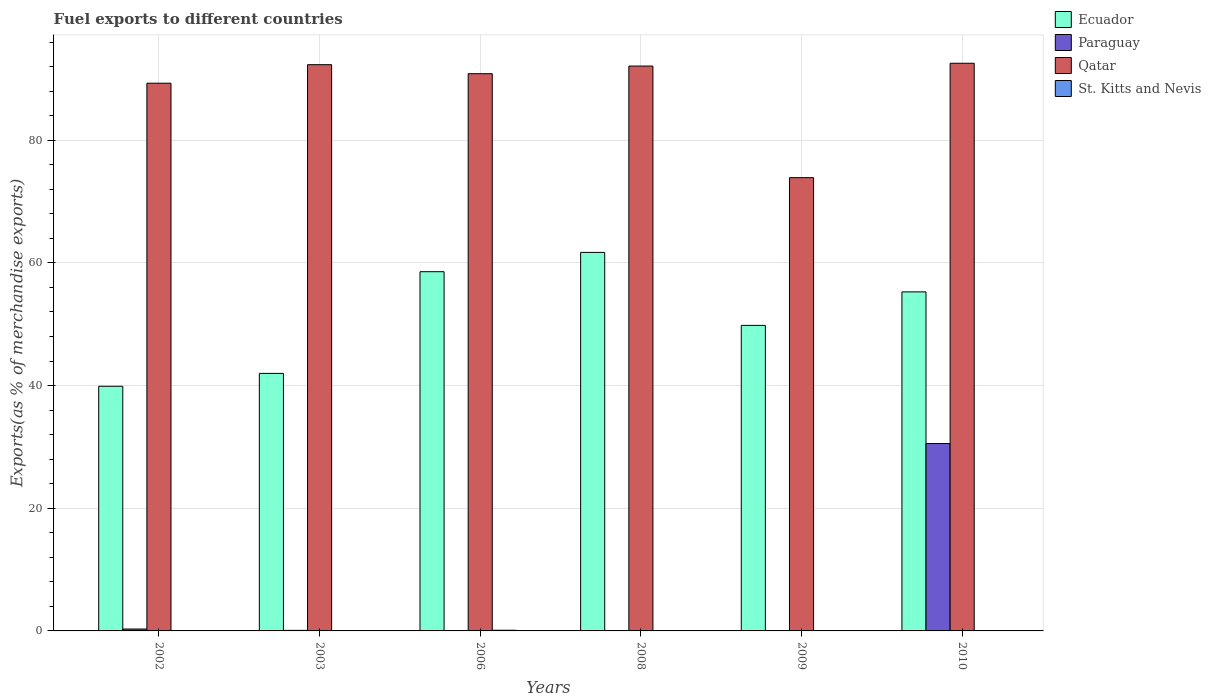How many different coloured bars are there?
Your answer should be compact. 4. What is the label of the 2nd group of bars from the left?
Ensure brevity in your answer.  2003. What is the percentage of exports to different countries in Ecuador in 2006?
Provide a succinct answer. 58.57. Across all years, what is the maximum percentage of exports to different countries in Qatar?
Make the answer very short. 92.55. Across all years, what is the minimum percentage of exports to different countries in Ecuador?
Keep it short and to the point. 39.89. What is the total percentage of exports to different countries in St. Kitts and Nevis in the graph?
Offer a very short reply. 0.13. What is the difference between the percentage of exports to different countries in St. Kitts and Nevis in 2002 and that in 2009?
Give a very brief answer. 0.01. What is the difference between the percentage of exports to different countries in Paraguay in 2006 and the percentage of exports to different countries in Qatar in 2002?
Ensure brevity in your answer.  -89.3. What is the average percentage of exports to different countries in St. Kitts and Nevis per year?
Your response must be concise. 0.02. In the year 2010, what is the difference between the percentage of exports to different countries in St. Kitts and Nevis and percentage of exports to different countries in Ecuador?
Your answer should be very brief. -55.28. What is the ratio of the percentage of exports to different countries in Qatar in 2008 to that in 2010?
Keep it short and to the point. 1. Is the percentage of exports to different countries in Ecuador in 2009 less than that in 2010?
Offer a very short reply. Yes. Is the difference between the percentage of exports to different countries in St. Kitts and Nevis in 2002 and 2008 greater than the difference between the percentage of exports to different countries in Ecuador in 2002 and 2008?
Your answer should be very brief. Yes. What is the difference between the highest and the second highest percentage of exports to different countries in Qatar?
Provide a short and direct response. 0.23. What is the difference between the highest and the lowest percentage of exports to different countries in Qatar?
Your answer should be very brief. 18.65. In how many years, is the percentage of exports to different countries in Qatar greater than the average percentage of exports to different countries in Qatar taken over all years?
Your answer should be compact. 5. Is the sum of the percentage of exports to different countries in Paraguay in 2003 and 2010 greater than the maximum percentage of exports to different countries in Ecuador across all years?
Your answer should be very brief. No. Is it the case that in every year, the sum of the percentage of exports to different countries in St. Kitts and Nevis and percentage of exports to different countries in Ecuador is greater than the sum of percentage of exports to different countries in Paraguay and percentage of exports to different countries in Qatar?
Provide a succinct answer. No. What does the 2nd bar from the left in 2009 represents?
Keep it short and to the point. Paraguay. What does the 2nd bar from the right in 2003 represents?
Your answer should be compact. Qatar. How many bars are there?
Your answer should be very brief. 24. Are the values on the major ticks of Y-axis written in scientific E-notation?
Offer a very short reply. No. Does the graph contain grids?
Give a very brief answer. Yes. How are the legend labels stacked?
Give a very brief answer. Vertical. What is the title of the graph?
Keep it short and to the point. Fuel exports to different countries. Does "Faeroe Islands" appear as one of the legend labels in the graph?
Your answer should be very brief. No. What is the label or title of the X-axis?
Ensure brevity in your answer.  Years. What is the label or title of the Y-axis?
Give a very brief answer. Exports(as % of merchandise exports). What is the Exports(as % of merchandise exports) of Ecuador in 2002?
Provide a succinct answer. 39.89. What is the Exports(as % of merchandise exports) of Paraguay in 2002?
Offer a terse response. 0.31. What is the Exports(as % of merchandise exports) of Qatar in 2002?
Your answer should be compact. 89.3. What is the Exports(as % of merchandise exports) in St. Kitts and Nevis in 2002?
Offer a very short reply. 0.01. What is the Exports(as % of merchandise exports) of Ecuador in 2003?
Offer a very short reply. 41.99. What is the Exports(as % of merchandise exports) in Paraguay in 2003?
Your response must be concise. 0.09. What is the Exports(as % of merchandise exports) in Qatar in 2003?
Offer a terse response. 92.32. What is the Exports(as % of merchandise exports) in St. Kitts and Nevis in 2003?
Offer a terse response. 0.01. What is the Exports(as % of merchandise exports) in Ecuador in 2006?
Your response must be concise. 58.57. What is the Exports(as % of merchandise exports) of Paraguay in 2006?
Make the answer very short. 1.68181738458249e-6. What is the Exports(as % of merchandise exports) in Qatar in 2006?
Ensure brevity in your answer.  90.85. What is the Exports(as % of merchandise exports) of St. Kitts and Nevis in 2006?
Provide a short and direct response. 0.11. What is the Exports(as % of merchandise exports) of Ecuador in 2008?
Ensure brevity in your answer.  61.72. What is the Exports(as % of merchandise exports) of Paraguay in 2008?
Your response must be concise. 0. What is the Exports(as % of merchandise exports) in Qatar in 2008?
Provide a succinct answer. 92.1. What is the Exports(as % of merchandise exports) of St. Kitts and Nevis in 2008?
Provide a short and direct response. 6.97416001647576e-6. What is the Exports(as % of merchandise exports) in Ecuador in 2009?
Give a very brief answer. 49.82. What is the Exports(as % of merchandise exports) of Paraguay in 2009?
Provide a short and direct response. 0.01. What is the Exports(as % of merchandise exports) of Qatar in 2009?
Offer a very short reply. 73.9. What is the Exports(as % of merchandise exports) of St. Kitts and Nevis in 2009?
Offer a very short reply. 0. What is the Exports(as % of merchandise exports) in Ecuador in 2010?
Your response must be concise. 55.28. What is the Exports(as % of merchandise exports) of Paraguay in 2010?
Provide a short and direct response. 30.55. What is the Exports(as % of merchandise exports) of Qatar in 2010?
Your response must be concise. 92.55. What is the Exports(as % of merchandise exports) of St. Kitts and Nevis in 2010?
Keep it short and to the point. 0. Across all years, what is the maximum Exports(as % of merchandise exports) of Ecuador?
Offer a terse response. 61.72. Across all years, what is the maximum Exports(as % of merchandise exports) in Paraguay?
Your response must be concise. 30.55. Across all years, what is the maximum Exports(as % of merchandise exports) in Qatar?
Offer a terse response. 92.55. Across all years, what is the maximum Exports(as % of merchandise exports) in St. Kitts and Nevis?
Provide a short and direct response. 0.11. Across all years, what is the minimum Exports(as % of merchandise exports) of Ecuador?
Your answer should be compact. 39.89. Across all years, what is the minimum Exports(as % of merchandise exports) in Paraguay?
Your response must be concise. 1.68181738458249e-6. Across all years, what is the minimum Exports(as % of merchandise exports) in Qatar?
Keep it short and to the point. 73.9. Across all years, what is the minimum Exports(as % of merchandise exports) in St. Kitts and Nevis?
Your answer should be compact. 6.97416001647576e-6. What is the total Exports(as % of merchandise exports) of Ecuador in the graph?
Ensure brevity in your answer.  307.26. What is the total Exports(as % of merchandise exports) of Paraguay in the graph?
Provide a succinct answer. 30.96. What is the total Exports(as % of merchandise exports) in Qatar in the graph?
Give a very brief answer. 531.04. What is the total Exports(as % of merchandise exports) in St. Kitts and Nevis in the graph?
Your answer should be compact. 0.13. What is the difference between the Exports(as % of merchandise exports) in Ecuador in 2002 and that in 2003?
Your answer should be compact. -2.1. What is the difference between the Exports(as % of merchandise exports) in Paraguay in 2002 and that in 2003?
Offer a very short reply. 0.22. What is the difference between the Exports(as % of merchandise exports) of Qatar in 2002 and that in 2003?
Keep it short and to the point. -3.02. What is the difference between the Exports(as % of merchandise exports) in St. Kitts and Nevis in 2002 and that in 2003?
Your answer should be compact. 0.01. What is the difference between the Exports(as % of merchandise exports) of Ecuador in 2002 and that in 2006?
Provide a succinct answer. -18.68. What is the difference between the Exports(as % of merchandise exports) of Paraguay in 2002 and that in 2006?
Ensure brevity in your answer.  0.31. What is the difference between the Exports(as % of merchandise exports) in Qatar in 2002 and that in 2006?
Your answer should be very brief. -1.55. What is the difference between the Exports(as % of merchandise exports) in St. Kitts and Nevis in 2002 and that in 2006?
Your response must be concise. -0.1. What is the difference between the Exports(as % of merchandise exports) of Ecuador in 2002 and that in 2008?
Give a very brief answer. -21.83. What is the difference between the Exports(as % of merchandise exports) in Paraguay in 2002 and that in 2008?
Your answer should be very brief. 0.31. What is the difference between the Exports(as % of merchandise exports) in Qatar in 2002 and that in 2008?
Keep it short and to the point. -2.79. What is the difference between the Exports(as % of merchandise exports) in St. Kitts and Nevis in 2002 and that in 2008?
Provide a succinct answer. 0.01. What is the difference between the Exports(as % of merchandise exports) of Ecuador in 2002 and that in 2009?
Keep it short and to the point. -9.93. What is the difference between the Exports(as % of merchandise exports) in Paraguay in 2002 and that in 2009?
Your answer should be very brief. 0.3. What is the difference between the Exports(as % of merchandise exports) in Qatar in 2002 and that in 2009?
Your answer should be very brief. 15.4. What is the difference between the Exports(as % of merchandise exports) in St. Kitts and Nevis in 2002 and that in 2009?
Provide a short and direct response. 0.01. What is the difference between the Exports(as % of merchandise exports) of Ecuador in 2002 and that in 2010?
Provide a succinct answer. -15.39. What is the difference between the Exports(as % of merchandise exports) of Paraguay in 2002 and that in 2010?
Offer a terse response. -30.24. What is the difference between the Exports(as % of merchandise exports) in Qatar in 2002 and that in 2010?
Make the answer very short. -3.25. What is the difference between the Exports(as % of merchandise exports) in St. Kitts and Nevis in 2002 and that in 2010?
Offer a very short reply. 0.01. What is the difference between the Exports(as % of merchandise exports) in Ecuador in 2003 and that in 2006?
Give a very brief answer. -16.58. What is the difference between the Exports(as % of merchandise exports) of Paraguay in 2003 and that in 2006?
Ensure brevity in your answer.  0.09. What is the difference between the Exports(as % of merchandise exports) in Qatar in 2003 and that in 2006?
Provide a succinct answer. 1.47. What is the difference between the Exports(as % of merchandise exports) in St. Kitts and Nevis in 2003 and that in 2006?
Your response must be concise. -0.1. What is the difference between the Exports(as % of merchandise exports) of Ecuador in 2003 and that in 2008?
Provide a succinct answer. -19.73. What is the difference between the Exports(as % of merchandise exports) in Paraguay in 2003 and that in 2008?
Offer a terse response. 0.09. What is the difference between the Exports(as % of merchandise exports) in Qatar in 2003 and that in 2008?
Your response must be concise. 0.23. What is the difference between the Exports(as % of merchandise exports) of St. Kitts and Nevis in 2003 and that in 2008?
Provide a succinct answer. 0.01. What is the difference between the Exports(as % of merchandise exports) of Ecuador in 2003 and that in 2009?
Your answer should be compact. -7.83. What is the difference between the Exports(as % of merchandise exports) of Paraguay in 2003 and that in 2009?
Your answer should be compact. 0.08. What is the difference between the Exports(as % of merchandise exports) in Qatar in 2003 and that in 2009?
Provide a short and direct response. 18.42. What is the difference between the Exports(as % of merchandise exports) of St. Kitts and Nevis in 2003 and that in 2009?
Give a very brief answer. 0.01. What is the difference between the Exports(as % of merchandise exports) in Ecuador in 2003 and that in 2010?
Give a very brief answer. -13.29. What is the difference between the Exports(as % of merchandise exports) in Paraguay in 2003 and that in 2010?
Provide a short and direct response. -30.46. What is the difference between the Exports(as % of merchandise exports) in Qatar in 2003 and that in 2010?
Your answer should be compact. -0.23. What is the difference between the Exports(as % of merchandise exports) of St. Kitts and Nevis in 2003 and that in 2010?
Your response must be concise. 0. What is the difference between the Exports(as % of merchandise exports) of Ecuador in 2006 and that in 2008?
Your response must be concise. -3.15. What is the difference between the Exports(as % of merchandise exports) of Paraguay in 2006 and that in 2008?
Provide a short and direct response. -0. What is the difference between the Exports(as % of merchandise exports) in Qatar in 2006 and that in 2008?
Provide a succinct answer. -1.25. What is the difference between the Exports(as % of merchandise exports) in St. Kitts and Nevis in 2006 and that in 2008?
Make the answer very short. 0.11. What is the difference between the Exports(as % of merchandise exports) in Ecuador in 2006 and that in 2009?
Give a very brief answer. 8.75. What is the difference between the Exports(as % of merchandise exports) of Paraguay in 2006 and that in 2009?
Offer a terse response. -0.01. What is the difference between the Exports(as % of merchandise exports) in Qatar in 2006 and that in 2009?
Keep it short and to the point. 16.95. What is the difference between the Exports(as % of merchandise exports) in St. Kitts and Nevis in 2006 and that in 2009?
Your answer should be compact. 0.11. What is the difference between the Exports(as % of merchandise exports) in Ecuador in 2006 and that in 2010?
Keep it short and to the point. 3.29. What is the difference between the Exports(as % of merchandise exports) of Paraguay in 2006 and that in 2010?
Your response must be concise. -30.55. What is the difference between the Exports(as % of merchandise exports) of Qatar in 2006 and that in 2010?
Your response must be concise. -1.7. What is the difference between the Exports(as % of merchandise exports) of St. Kitts and Nevis in 2006 and that in 2010?
Ensure brevity in your answer.  0.11. What is the difference between the Exports(as % of merchandise exports) in Ecuador in 2008 and that in 2009?
Offer a terse response. 11.9. What is the difference between the Exports(as % of merchandise exports) in Paraguay in 2008 and that in 2009?
Make the answer very short. -0.01. What is the difference between the Exports(as % of merchandise exports) in Qatar in 2008 and that in 2009?
Offer a very short reply. 18.2. What is the difference between the Exports(as % of merchandise exports) of St. Kitts and Nevis in 2008 and that in 2009?
Provide a succinct answer. -0. What is the difference between the Exports(as % of merchandise exports) of Ecuador in 2008 and that in 2010?
Provide a short and direct response. 6.44. What is the difference between the Exports(as % of merchandise exports) in Paraguay in 2008 and that in 2010?
Ensure brevity in your answer.  -30.55. What is the difference between the Exports(as % of merchandise exports) of Qatar in 2008 and that in 2010?
Ensure brevity in your answer.  -0.46. What is the difference between the Exports(as % of merchandise exports) of St. Kitts and Nevis in 2008 and that in 2010?
Offer a terse response. -0. What is the difference between the Exports(as % of merchandise exports) in Ecuador in 2009 and that in 2010?
Make the answer very short. -5.46. What is the difference between the Exports(as % of merchandise exports) of Paraguay in 2009 and that in 2010?
Provide a succinct answer. -30.54. What is the difference between the Exports(as % of merchandise exports) of Qatar in 2009 and that in 2010?
Your answer should be very brief. -18.65. What is the difference between the Exports(as % of merchandise exports) of St. Kitts and Nevis in 2009 and that in 2010?
Give a very brief answer. -0. What is the difference between the Exports(as % of merchandise exports) of Ecuador in 2002 and the Exports(as % of merchandise exports) of Paraguay in 2003?
Make the answer very short. 39.8. What is the difference between the Exports(as % of merchandise exports) in Ecuador in 2002 and the Exports(as % of merchandise exports) in Qatar in 2003?
Provide a short and direct response. -52.44. What is the difference between the Exports(as % of merchandise exports) in Ecuador in 2002 and the Exports(as % of merchandise exports) in St. Kitts and Nevis in 2003?
Offer a terse response. 39.88. What is the difference between the Exports(as % of merchandise exports) in Paraguay in 2002 and the Exports(as % of merchandise exports) in Qatar in 2003?
Offer a very short reply. -92.01. What is the difference between the Exports(as % of merchandise exports) of Paraguay in 2002 and the Exports(as % of merchandise exports) of St. Kitts and Nevis in 2003?
Your answer should be compact. 0.3. What is the difference between the Exports(as % of merchandise exports) in Qatar in 2002 and the Exports(as % of merchandise exports) in St. Kitts and Nevis in 2003?
Your response must be concise. 89.3. What is the difference between the Exports(as % of merchandise exports) in Ecuador in 2002 and the Exports(as % of merchandise exports) in Paraguay in 2006?
Make the answer very short. 39.89. What is the difference between the Exports(as % of merchandise exports) in Ecuador in 2002 and the Exports(as % of merchandise exports) in Qatar in 2006?
Make the answer very short. -50.96. What is the difference between the Exports(as % of merchandise exports) of Ecuador in 2002 and the Exports(as % of merchandise exports) of St. Kitts and Nevis in 2006?
Your answer should be very brief. 39.78. What is the difference between the Exports(as % of merchandise exports) in Paraguay in 2002 and the Exports(as % of merchandise exports) in Qatar in 2006?
Your answer should be very brief. -90.54. What is the difference between the Exports(as % of merchandise exports) of Paraguay in 2002 and the Exports(as % of merchandise exports) of St. Kitts and Nevis in 2006?
Your response must be concise. 0.2. What is the difference between the Exports(as % of merchandise exports) of Qatar in 2002 and the Exports(as % of merchandise exports) of St. Kitts and Nevis in 2006?
Give a very brief answer. 89.19. What is the difference between the Exports(as % of merchandise exports) of Ecuador in 2002 and the Exports(as % of merchandise exports) of Paraguay in 2008?
Keep it short and to the point. 39.89. What is the difference between the Exports(as % of merchandise exports) of Ecuador in 2002 and the Exports(as % of merchandise exports) of Qatar in 2008?
Make the answer very short. -52.21. What is the difference between the Exports(as % of merchandise exports) of Ecuador in 2002 and the Exports(as % of merchandise exports) of St. Kitts and Nevis in 2008?
Make the answer very short. 39.89. What is the difference between the Exports(as % of merchandise exports) of Paraguay in 2002 and the Exports(as % of merchandise exports) of Qatar in 2008?
Provide a succinct answer. -91.79. What is the difference between the Exports(as % of merchandise exports) of Paraguay in 2002 and the Exports(as % of merchandise exports) of St. Kitts and Nevis in 2008?
Offer a very short reply. 0.31. What is the difference between the Exports(as % of merchandise exports) of Qatar in 2002 and the Exports(as % of merchandise exports) of St. Kitts and Nevis in 2008?
Make the answer very short. 89.3. What is the difference between the Exports(as % of merchandise exports) of Ecuador in 2002 and the Exports(as % of merchandise exports) of Paraguay in 2009?
Keep it short and to the point. 39.88. What is the difference between the Exports(as % of merchandise exports) in Ecuador in 2002 and the Exports(as % of merchandise exports) in Qatar in 2009?
Your answer should be very brief. -34.01. What is the difference between the Exports(as % of merchandise exports) in Ecuador in 2002 and the Exports(as % of merchandise exports) in St. Kitts and Nevis in 2009?
Offer a terse response. 39.89. What is the difference between the Exports(as % of merchandise exports) of Paraguay in 2002 and the Exports(as % of merchandise exports) of Qatar in 2009?
Provide a short and direct response. -73.59. What is the difference between the Exports(as % of merchandise exports) of Paraguay in 2002 and the Exports(as % of merchandise exports) of St. Kitts and Nevis in 2009?
Offer a terse response. 0.31. What is the difference between the Exports(as % of merchandise exports) of Qatar in 2002 and the Exports(as % of merchandise exports) of St. Kitts and Nevis in 2009?
Provide a succinct answer. 89.3. What is the difference between the Exports(as % of merchandise exports) of Ecuador in 2002 and the Exports(as % of merchandise exports) of Paraguay in 2010?
Make the answer very short. 9.34. What is the difference between the Exports(as % of merchandise exports) in Ecuador in 2002 and the Exports(as % of merchandise exports) in Qatar in 2010?
Make the answer very short. -52.67. What is the difference between the Exports(as % of merchandise exports) in Ecuador in 2002 and the Exports(as % of merchandise exports) in St. Kitts and Nevis in 2010?
Your response must be concise. 39.89. What is the difference between the Exports(as % of merchandise exports) in Paraguay in 2002 and the Exports(as % of merchandise exports) in Qatar in 2010?
Your answer should be very brief. -92.24. What is the difference between the Exports(as % of merchandise exports) in Paraguay in 2002 and the Exports(as % of merchandise exports) in St. Kitts and Nevis in 2010?
Your response must be concise. 0.31. What is the difference between the Exports(as % of merchandise exports) in Qatar in 2002 and the Exports(as % of merchandise exports) in St. Kitts and Nevis in 2010?
Offer a terse response. 89.3. What is the difference between the Exports(as % of merchandise exports) of Ecuador in 2003 and the Exports(as % of merchandise exports) of Paraguay in 2006?
Provide a succinct answer. 41.99. What is the difference between the Exports(as % of merchandise exports) in Ecuador in 2003 and the Exports(as % of merchandise exports) in Qatar in 2006?
Your answer should be very brief. -48.87. What is the difference between the Exports(as % of merchandise exports) in Ecuador in 2003 and the Exports(as % of merchandise exports) in St. Kitts and Nevis in 2006?
Ensure brevity in your answer.  41.88. What is the difference between the Exports(as % of merchandise exports) of Paraguay in 2003 and the Exports(as % of merchandise exports) of Qatar in 2006?
Provide a succinct answer. -90.76. What is the difference between the Exports(as % of merchandise exports) of Paraguay in 2003 and the Exports(as % of merchandise exports) of St. Kitts and Nevis in 2006?
Give a very brief answer. -0.02. What is the difference between the Exports(as % of merchandise exports) of Qatar in 2003 and the Exports(as % of merchandise exports) of St. Kitts and Nevis in 2006?
Your answer should be very brief. 92.21. What is the difference between the Exports(as % of merchandise exports) of Ecuador in 2003 and the Exports(as % of merchandise exports) of Paraguay in 2008?
Provide a succinct answer. 41.99. What is the difference between the Exports(as % of merchandise exports) of Ecuador in 2003 and the Exports(as % of merchandise exports) of Qatar in 2008?
Your response must be concise. -50.11. What is the difference between the Exports(as % of merchandise exports) in Ecuador in 2003 and the Exports(as % of merchandise exports) in St. Kitts and Nevis in 2008?
Provide a succinct answer. 41.99. What is the difference between the Exports(as % of merchandise exports) of Paraguay in 2003 and the Exports(as % of merchandise exports) of Qatar in 2008?
Offer a terse response. -92.01. What is the difference between the Exports(as % of merchandise exports) in Paraguay in 2003 and the Exports(as % of merchandise exports) in St. Kitts and Nevis in 2008?
Keep it short and to the point. 0.09. What is the difference between the Exports(as % of merchandise exports) of Qatar in 2003 and the Exports(as % of merchandise exports) of St. Kitts and Nevis in 2008?
Make the answer very short. 92.32. What is the difference between the Exports(as % of merchandise exports) of Ecuador in 2003 and the Exports(as % of merchandise exports) of Paraguay in 2009?
Your answer should be very brief. 41.98. What is the difference between the Exports(as % of merchandise exports) of Ecuador in 2003 and the Exports(as % of merchandise exports) of Qatar in 2009?
Ensure brevity in your answer.  -31.91. What is the difference between the Exports(as % of merchandise exports) in Ecuador in 2003 and the Exports(as % of merchandise exports) in St. Kitts and Nevis in 2009?
Your answer should be compact. 41.99. What is the difference between the Exports(as % of merchandise exports) in Paraguay in 2003 and the Exports(as % of merchandise exports) in Qatar in 2009?
Ensure brevity in your answer.  -73.81. What is the difference between the Exports(as % of merchandise exports) of Paraguay in 2003 and the Exports(as % of merchandise exports) of St. Kitts and Nevis in 2009?
Ensure brevity in your answer.  0.09. What is the difference between the Exports(as % of merchandise exports) of Qatar in 2003 and the Exports(as % of merchandise exports) of St. Kitts and Nevis in 2009?
Make the answer very short. 92.32. What is the difference between the Exports(as % of merchandise exports) of Ecuador in 2003 and the Exports(as % of merchandise exports) of Paraguay in 2010?
Provide a short and direct response. 11.44. What is the difference between the Exports(as % of merchandise exports) in Ecuador in 2003 and the Exports(as % of merchandise exports) in Qatar in 2010?
Your response must be concise. -50.57. What is the difference between the Exports(as % of merchandise exports) of Ecuador in 2003 and the Exports(as % of merchandise exports) of St. Kitts and Nevis in 2010?
Give a very brief answer. 41.98. What is the difference between the Exports(as % of merchandise exports) in Paraguay in 2003 and the Exports(as % of merchandise exports) in Qatar in 2010?
Your response must be concise. -92.46. What is the difference between the Exports(as % of merchandise exports) in Paraguay in 2003 and the Exports(as % of merchandise exports) in St. Kitts and Nevis in 2010?
Your answer should be compact. 0.09. What is the difference between the Exports(as % of merchandise exports) in Qatar in 2003 and the Exports(as % of merchandise exports) in St. Kitts and Nevis in 2010?
Give a very brief answer. 92.32. What is the difference between the Exports(as % of merchandise exports) of Ecuador in 2006 and the Exports(as % of merchandise exports) of Paraguay in 2008?
Provide a succinct answer. 58.57. What is the difference between the Exports(as % of merchandise exports) of Ecuador in 2006 and the Exports(as % of merchandise exports) of Qatar in 2008?
Provide a short and direct response. -33.53. What is the difference between the Exports(as % of merchandise exports) of Ecuador in 2006 and the Exports(as % of merchandise exports) of St. Kitts and Nevis in 2008?
Your response must be concise. 58.57. What is the difference between the Exports(as % of merchandise exports) of Paraguay in 2006 and the Exports(as % of merchandise exports) of Qatar in 2008?
Your answer should be compact. -92.1. What is the difference between the Exports(as % of merchandise exports) in Paraguay in 2006 and the Exports(as % of merchandise exports) in St. Kitts and Nevis in 2008?
Provide a succinct answer. -0. What is the difference between the Exports(as % of merchandise exports) in Qatar in 2006 and the Exports(as % of merchandise exports) in St. Kitts and Nevis in 2008?
Your answer should be very brief. 90.85. What is the difference between the Exports(as % of merchandise exports) in Ecuador in 2006 and the Exports(as % of merchandise exports) in Paraguay in 2009?
Ensure brevity in your answer.  58.56. What is the difference between the Exports(as % of merchandise exports) of Ecuador in 2006 and the Exports(as % of merchandise exports) of Qatar in 2009?
Keep it short and to the point. -15.33. What is the difference between the Exports(as % of merchandise exports) in Ecuador in 2006 and the Exports(as % of merchandise exports) in St. Kitts and Nevis in 2009?
Offer a very short reply. 58.57. What is the difference between the Exports(as % of merchandise exports) in Paraguay in 2006 and the Exports(as % of merchandise exports) in Qatar in 2009?
Your response must be concise. -73.9. What is the difference between the Exports(as % of merchandise exports) in Paraguay in 2006 and the Exports(as % of merchandise exports) in St. Kitts and Nevis in 2009?
Ensure brevity in your answer.  -0. What is the difference between the Exports(as % of merchandise exports) of Qatar in 2006 and the Exports(as % of merchandise exports) of St. Kitts and Nevis in 2009?
Give a very brief answer. 90.85. What is the difference between the Exports(as % of merchandise exports) of Ecuador in 2006 and the Exports(as % of merchandise exports) of Paraguay in 2010?
Give a very brief answer. 28.02. What is the difference between the Exports(as % of merchandise exports) in Ecuador in 2006 and the Exports(as % of merchandise exports) in Qatar in 2010?
Keep it short and to the point. -33.98. What is the difference between the Exports(as % of merchandise exports) in Ecuador in 2006 and the Exports(as % of merchandise exports) in St. Kitts and Nevis in 2010?
Your answer should be very brief. 58.57. What is the difference between the Exports(as % of merchandise exports) in Paraguay in 2006 and the Exports(as % of merchandise exports) in Qatar in 2010?
Your answer should be compact. -92.55. What is the difference between the Exports(as % of merchandise exports) of Paraguay in 2006 and the Exports(as % of merchandise exports) of St. Kitts and Nevis in 2010?
Give a very brief answer. -0. What is the difference between the Exports(as % of merchandise exports) in Qatar in 2006 and the Exports(as % of merchandise exports) in St. Kitts and Nevis in 2010?
Keep it short and to the point. 90.85. What is the difference between the Exports(as % of merchandise exports) of Ecuador in 2008 and the Exports(as % of merchandise exports) of Paraguay in 2009?
Provide a succinct answer. 61.71. What is the difference between the Exports(as % of merchandise exports) of Ecuador in 2008 and the Exports(as % of merchandise exports) of Qatar in 2009?
Give a very brief answer. -12.19. What is the difference between the Exports(as % of merchandise exports) in Ecuador in 2008 and the Exports(as % of merchandise exports) in St. Kitts and Nevis in 2009?
Offer a very short reply. 61.72. What is the difference between the Exports(as % of merchandise exports) in Paraguay in 2008 and the Exports(as % of merchandise exports) in Qatar in 2009?
Provide a short and direct response. -73.9. What is the difference between the Exports(as % of merchandise exports) of Qatar in 2008 and the Exports(as % of merchandise exports) of St. Kitts and Nevis in 2009?
Offer a very short reply. 92.1. What is the difference between the Exports(as % of merchandise exports) in Ecuador in 2008 and the Exports(as % of merchandise exports) in Paraguay in 2010?
Offer a terse response. 31.16. What is the difference between the Exports(as % of merchandise exports) of Ecuador in 2008 and the Exports(as % of merchandise exports) of Qatar in 2010?
Offer a terse response. -30.84. What is the difference between the Exports(as % of merchandise exports) in Ecuador in 2008 and the Exports(as % of merchandise exports) in St. Kitts and Nevis in 2010?
Provide a succinct answer. 61.71. What is the difference between the Exports(as % of merchandise exports) of Paraguay in 2008 and the Exports(as % of merchandise exports) of Qatar in 2010?
Provide a succinct answer. -92.55. What is the difference between the Exports(as % of merchandise exports) of Paraguay in 2008 and the Exports(as % of merchandise exports) of St. Kitts and Nevis in 2010?
Your answer should be very brief. -0. What is the difference between the Exports(as % of merchandise exports) in Qatar in 2008 and the Exports(as % of merchandise exports) in St. Kitts and Nevis in 2010?
Offer a very short reply. 92.1. What is the difference between the Exports(as % of merchandise exports) in Ecuador in 2009 and the Exports(as % of merchandise exports) in Paraguay in 2010?
Make the answer very short. 19.26. What is the difference between the Exports(as % of merchandise exports) in Ecuador in 2009 and the Exports(as % of merchandise exports) in Qatar in 2010?
Offer a terse response. -42.74. What is the difference between the Exports(as % of merchandise exports) of Ecuador in 2009 and the Exports(as % of merchandise exports) of St. Kitts and Nevis in 2010?
Offer a very short reply. 49.81. What is the difference between the Exports(as % of merchandise exports) in Paraguay in 2009 and the Exports(as % of merchandise exports) in Qatar in 2010?
Your response must be concise. -92.55. What is the difference between the Exports(as % of merchandise exports) in Paraguay in 2009 and the Exports(as % of merchandise exports) in St. Kitts and Nevis in 2010?
Ensure brevity in your answer.  0.01. What is the difference between the Exports(as % of merchandise exports) in Qatar in 2009 and the Exports(as % of merchandise exports) in St. Kitts and Nevis in 2010?
Offer a very short reply. 73.9. What is the average Exports(as % of merchandise exports) of Ecuador per year?
Give a very brief answer. 51.21. What is the average Exports(as % of merchandise exports) of Paraguay per year?
Keep it short and to the point. 5.16. What is the average Exports(as % of merchandise exports) of Qatar per year?
Your answer should be compact. 88.51. What is the average Exports(as % of merchandise exports) of St. Kitts and Nevis per year?
Keep it short and to the point. 0.02. In the year 2002, what is the difference between the Exports(as % of merchandise exports) in Ecuador and Exports(as % of merchandise exports) in Paraguay?
Your answer should be very brief. 39.58. In the year 2002, what is the difference between the Exports(as % of merchandise exports) of Ecuador and Exports(as % of merchandise exports) of Qatar?
Offer a very short reply. -49.42. In the year 2002, what is the difference between the Exports(as % of merchandise exports) of Ecuador and Exports(as % of merchandise exports) of St. Kitts and Nevis?
Offer a terse response. 39.88. In the year 2002, what is the difference between the Exports(as % of merchandise exports) in Paraguay and Exports(as % of merchandise exports) in Qatar?
Keep it short and to the point. -88.99. In the year 2002, what is the difference between the Exports(as % of merchandise exports) of Paraguay and Exports(as % of merchandise exports) of St. Kitts and Nevis?
Provide a succinct answer. 0.3. In the year 2002, what is the difference between the Exports(as % of merchandise exports) in Qatar and Exports(as % of merchandise exports) in St. Kitts and Nevis?
Keep it short and to the point. 89.29. In the year 2003, what is the difference between the Exports(as % of merchandise exports) of Ecuador and Exports(as % of merchandise exports) of Paraguay?
Provide a succinct answer. 41.9. In the year 2003, what is the difference between the Exports(as % of merchandise exports) in Ecuador and Exports(as % of merchandise exports) in Qatar?
Your answer should be compact. -50.34. In the year 2003, what is the difference between the Exports(as % of merchandise exports) of Ecuador and Exports(as % of merchandise exports) of St. Kitts and Nevis?
Provide a succinct answer. 41.98. In the year 2003, what is the difference between the Exports(as % of merchandise exports) of Paraguay and Exports(as % of merchandise exports) of Qatar?
Your response must be concise. -92.23. In the year 2003, what is the difference between the Exports(as % of merchandise exports) of Paraguay and Exports(as % of merchandise exports) of St. Kitts and Nevis?
Make the answer very short. 0.09. In the year 2003, what is the difference between the Exports(as % of merchandise exports) of Qatar and Exports(as % of merchandise exports) of St. Kitts and Nevis?
Offer a terse response. 92.32. In the year 2006, what is the difference between the Exports(as % of merchandise exports) in Ecuador and Exports(as % of merchandise exports) in Paraguay?
Offer a terse response. 58.57. In the year 2006, what is the difference between the Exports(as % of merchandise exports) of Ecuador and Exports(as % of merchandise exports) of Qatar?
Your answer should be compact. -32.28. In the year 2006, what is the difference between the Exports(as % of merchandise exports) of Ecuador and Exports(as % of merchandise exports) of St. Kitts and Nevis?
Ensure brevity in your answer.  58.46. In the year 2006, what is the difference between the Exports(as % of merchandise exports) of Paraguay and Exports(as % of merchandise exports) of Qatar?
Provide a short and direct response. -90.85. In the year 2006, what is the difference between the Exports(as % of merchandise exports) of Paraguay and Exports(as % of merchandise exports) of St. Kitts and Nevis?
Provide a short and direct response. -0.11. In the year 2006, what is the difference between the Exports(as % of merchandise exports) in Qatar and Exports(as % of merchandise exports) in St. Kitts and Nevis?
Your answer should be very brief. 90.74. In the year 2008, what is the difference between the Exports(as % of merchandise exports) in Ecuador and Exports(as % of merchandise exports) in Paraguay?
Your answer should be compact. 61.72. In the year 2008, what is the difference between the Exports(as % of merchandise exports) in Ecuador and Exports(as % of merchandise exports) in Qatar?
Make the answer very short. -30.38. In the year 2008, what is the difference between the Exports(as % of merchandise exports) of Ecuador and Exports(as % of merchandise exports) of St. Kitts and Nevis?
Your answer should be compact. 61.72. In the year 2008, what is the difference between the Exports(as % of merchandise exports) of Paraguay and Exports(as % of merchandise exports) of Qatar?
Your response must be concise. -92.1. In the year 2008, what is the difference between the Exports(as % of merchandise exports) of Qatar and Exports(as % of merchandise exports) of St. Kitts and Nevis?
Offer a very short reply. 92.1. In the year 2009, what is the difference between the Exports(as % of merchandise exports) of Ecuador and Exports(as % of merchandise exports) of Paraguay?
Offer a very short reply. 49.81. In the year 2009, what is the difference between the Exports(as % of merchandise exports) in Ecuador and Exports(as % of merchandise exports) in Qatar?
Provide a succinct answer. -24.09. In the year 2009, what is the difference between the Exports(as % of merchandise exports) of Ecuador and Exports(as % of merchandise exports) of St. Kitts and Nevis?
Make the answer very short. 49.82. In the year 2009, what is the difference between the Exports(as % of merchandise exports) of Paraguay and Exports(as % of merchandise exports) of Qatar?
Provide a short and direct response. -73.89. In the year 2009, what is the difference between the Exports(as % of merchandise exports) of Paraguay and Exports(as % of merchandise exports) of St. Kitts and Nevis?
Your answer should be compact. 0.01. In the year 2009, what is the difference between the Exports(as % of merchandise exports) of Qatar and Exports(as % of merchandise exports) of St. Kitts and Nevis?
Ensure brevity in your answer.  73.9. In the year 2010, what is the difference between the Exports(as % of merchandise exports) of Ecuador and Exports(as % of merchandise exports) of Paraguay?
Offer a very short reply. 24.73. In the year 2010, what is the difference between the Exports(as % of merchandise exports) of Ecuador and Exports(as % of merchandise exports) of Qatar?
Keep it short and to the point. -37.28. In the year 2010, what is the difference between the Exports(as % of merchandise exports) of Ecuador and Exports(as % of merchandise exports) of St. Kitts and Nevis?
Your response must be concise. 55.28. In the year 2010, what is the difference between the Exports(as % of merchandise exports) in Paraguay and Exports(as % of merchandise exports) in Qatar?
Offer a terse response. -62. In the year 2010, what is the difference between the Exports(as % of merchandise exports) in Paraguay and Exports(as % of merchandise exports) in St. Kitts and Nevis?
Provide a succinct answer. 30.55. In the year 2010, what is the difference between the Exports(as % of merchandise exports) in Qatar and Exports(as % of merchandise exports) in St. Kitts and Nevis?
Ensure brevity in your answer.  92.55. What is the ratio of the Exports(as % of merchandise exports) in Paraguay in 2002 to that in 2003?
Provide a succinct answer. 3.4. What is the ratio of the Exports(as % of merchandise exports) in Qatar in 2002 to that in 2003?
Ensure brevity in your answer.  0.97. What is the ratio of the Exports(as % of merchandise exports) in St. Kitts and Nevis in 2002 to that in 2003?
Provide a succinct answer. 2.3. What is the ratio of the Exports(as % of merchandise exports) of Ecuador in 2002 to that in 2006?
Your answer should be compact. 0.68. What is the ratio of the Exports(as % of merchandise exports) in Paraguay in 2002 to that in 2006?
Keep it short and to the point. 1.84e+05. What is the ratio of the Exports(as % of merchandise exports) in St. Kitts and Nevis in 2002 to that in 2006?
Offer a very short reply. 0.12. What is the ratio of the Exports(as % of merchandise exports) of Ecuador in 2002 to that in 2008?
Give a very brief answer. 0.65. What is the ratio of the Exports(as % of merchandise exports) in Paraguay in 2002 to that in 2008?
Offer a very short reply. 1339.89. What is the ratio of the Exports(as % of merchandise exports) in Qatar in 2002 to that in 2008?
Provide a short and direct response. 0.97. What is the ratio of the Exports(as % of merchandise exports) of St. Kitts and Nevis in 2002 to that in 2008?
Your answer should be compact. 1974.92. What is the ratio of the Exports(as % of merchandise exports) in Ecuador in 2002 to that in 2009?
Your answer should be very brief. 0.8. What is the ratio of the Exports(as % of merchandise exports) in Paraguay in 2002 to that in 2009?
Offer a terse response. 36.21. What is the ratio of the Exports(as % of merchandise exports) of Qatar in 2002 to that in 2009?
Give a very brief answer. 1.21. What is the ratio of the Exports(as % of merchandise exports) in St. Kitts and Nevis in 2002 to that in 2009?
Your answer should be compact. 128.86. What is the ratio of the Exports(as % of merchandise exports) in Ecuador in 2002 to that in 2010?
Provide a short and direct response. 0.72. What is the ratio of the Exports(as % of merchandise exports) of Paraguay in 2002 to that in 2010?
Your answer should be compact. 0.01. What is the ratio of the Exports(as % of merchandise exports) of Qatar in 2002 to that in 2010?
Your answer should be very brief. 0.96. What is the ratio of the Exports(as % of merchandise exports) in St. Kitts and Nevis in 2002 to that in 2010?
Offer a very short reply. 4.17. What is the ratio of the Exports(as % of merchandise exports) in Ecuador in 2003 to that in 2006?
Keep it short and to the point. 0.72. What is the ratio of the Exports(as % of merchandise exports) of Paraguay in 2003 to that in 2006?
Keep it short and to the point. 5.42e+04. What is the ratio of the Exports(as % of merchandise exports) in Qatar in 2003 to that in 2006?
Provide a short and direct response. 1.02. What is the ratio of the Exports(as % of merchandise exports) of St. Kitts and Nevis in 2003 to that in 2006?
Provide a succinct answer. 0.05. What is the ratio of the Exports(as % of merchandise exports) in Ecuador in 2003 to that in 2008?
Your answer should be very brief. 0.68. What is the ratio of the Exports(as % of merchandise exports) of Paraguay in 2003 to that in 2008?
Give a very brief answer. 393.65. What is the ratio of the Exports(as % of merchandise exports) in Qatar in 2003 to that in 2008?
Make the answer very short. 1. What is the ratio of the Exports(as % of merchandise exports) in St. Kitts and Nevis in 2003 to that in 2008?
Provide a succinct answer. 859.39. What is the ratio of the Exports(as % of merchandise exports) in Ecuador in 2003 to that in 2009?
Offer a very short reply. 0.84. What is the ratio of the Exports(as % of merchandise exports) in Paraguay in 2003 to that in 2009?
Your answer should be very brief. 10.64. What is the ratio of the Exports(as % of merchandise exports) in Qatar in 2003 to that in 2009?
Offer a very short reply. 1.25. What is the ratio of the Exports(as % of merchandise exports) in St. Kitts and Nevis in 2003 to that in 2009?
Offer a terse response. 56.07. What is the ratio of the Exports(as % of merchandise exports) of Ecuador in 2003 to that in 2010?
Your response must be concise. 0.76. What is the ratio of the Exports(as % of merchandise exports) of Paraguay in 2003 to that in 2010?
Your response must be concise. 0. What is the ratio of the Exports(as % of merchandise exports) of St. Kitts and Nevis in 2003 to that in 2010?
Give a very brief answer. 1.81. What is the ratio of the Exports(as % of merchandise exports) of Ecuador in 2006 to that in 2008?
Ensure brevity in your answer.  0.95. What is the ratio of the Exports(as % of merchandise exports) of Paraguay in 2006 to that in 2008?
Give a very brief answer. 0.01. What is the ratio of the Exports(as % of merchandise exports) of Qatar in 2006 to that in 2008?
Keep it short and to the point. 0.99. What is the ratio of the Exports(as % of merchandise exports) in St. Kitts and Nevis in 2006 to that in 2008?
Provide a short and direct response. 1.59e+04. What is the ratio of the Exports(as % of merchandise exports) of Ecuador in 2006 to that in 2009?
Provide a short and direct response. 1.18. What is the ratio of the Exports(as % of merchandise exports) of Paraguay in 2006 to that in 2009?
Offer a very short reply. 0. What is the ratio of the Exports(as % of merchandise exports) in Qatar in 2006 to that in 2009?
Offer a very short reply. 1.23. What is the ratio of the Exports(as % of merchandise exports) of St. Kitts and Nevis in 2006 to that in 2009?
Provide a succinct answer. 1038.21. What is the ratio of the Exports(as % of merchandise exports) of Ecuador in 2006 to that in 2010?
Give a very brief answer. 1.06. What is the ratio of the Exports(as % of merchandise exports) in Qatar in 2006 to that in 2010?
Provide a succinct answer. 0.98. What is the ratio of the Exports(as % of merchandise exports) in St. Kitts and Nevis in 2006 to that in 2010?
Make the answer very short. 33.59. What is the ratio of the Exports(as % of merchandise exports) in Ecuador in 2008 to that in 2009?
Ensure brevity in your answer.  1.24. What is the ratio of the Exports(as % of merchandise exports) in Paraguay in 2008 to that in 2009?
Provide a short and direct response. 0.03. What is the ratio of the Exports(as % of merchandise exports) in Qatar in 2008 to that in 2009?
Your response must be concise. 1.25. What is the ratio of the Exports(as % of merchandise exports) in St. Kitts and Nevis in 2008 to that in 2009?
Make the answer very short. 0.07. What is the ratio of the Exports(as % of merchandise exports) in Ecuador in 2008 to that in 2010?
Ensure brevity in your answer.  1.12. What is the ratio of the Exports(as % of merchandise exports) of St. Kitts and Nevis in 2008 to that in 2010?
Your answer should be very brief. 0. What is the ratio of the Exports(as % of merchandise exports) of Ecuador in 2009 to that in 2010?
Keep it short and to the point. 0.9. What is the ratio of the Exports(as % of merchandise exports) of Paraguay in 2009 to that in 2010?
Your answer should be compact. 0. What is the ratio of the Exports(as % of merchandise exports) in Qatar in 2009 to that in 2010?
Provide a succinct answer. 0.8. What is the ratio of the Exports(as % of merchandise exports) of St. Kitts and Nevis in 2009 to that in 2010?
Keep it short and to the point. 0.03. What is the difference between the highest and the second highest Exports(as % of merchandise exports) of Ecuador?
Your answer should be very brief. 3.15. What is the difference between the highest and the second highest Exports(as % of merchandise exports) of Paraguay?
Offer a very short reply. 30.24. What is the difference between the highest and the second highest Exports(as % of merchandise exports) of Qatar?
Your answer should be compact. 0.23. What is the difference between the highest and the second highest Exports(as % of merchandise exports) of St. Kitts and Nevis?
Your answer should be very brief. 0.1. What is the difference between the highest and the lowest Exports(as % of merchandise exports) in Ecuador?
Your answer should be compact. 21.83. What is the difference between the highest and the lowest Exports(as % of merchandise exports) in Paraguay?
Keep it short and to the point. 30.55. What is the difference between the highest and the lowest Exports(as % of merchandise exports) of Qatar?
Ensure brevity in your answer.  18.65. What is the difference between the highest and the lowest Exports(as % of merchandise exports) of St. Kitts and Nevis?
Your answer should be very brief. 0.11. 